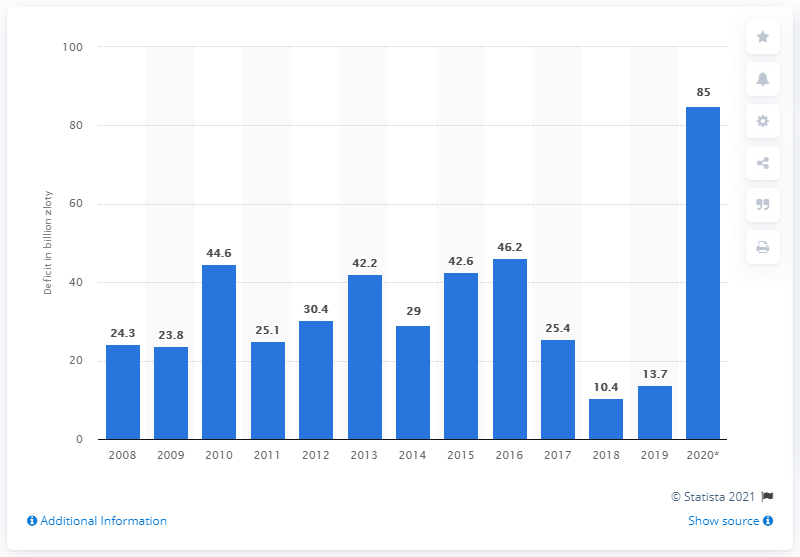Indicate a few pertinent items in this graphic. In 2020, the budget loss in Poland was 85. 